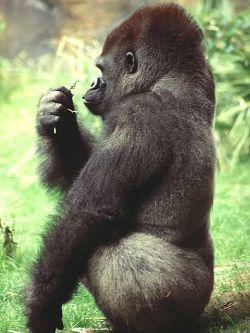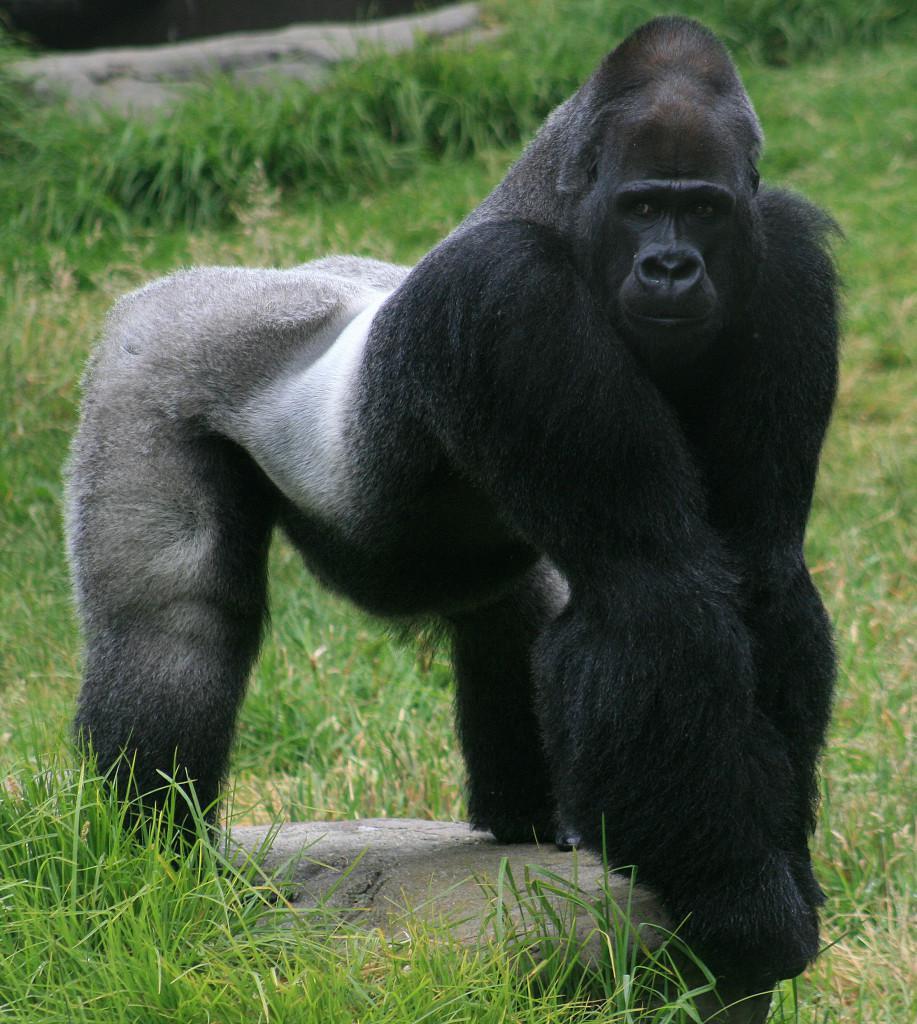The first image is the image on the left, the second image is the image on the right. Given the left and right images, does the statement "The left image contains a gorilla sitting down and looking towards the right." hold true? Answer yes or no. No. The first image is the image on the left, the second image is the image on the right. For the images shown, is this caption "The baboon on the left is holding a baby baboon and sitting on the grass." true? Answer yes or no. No. 